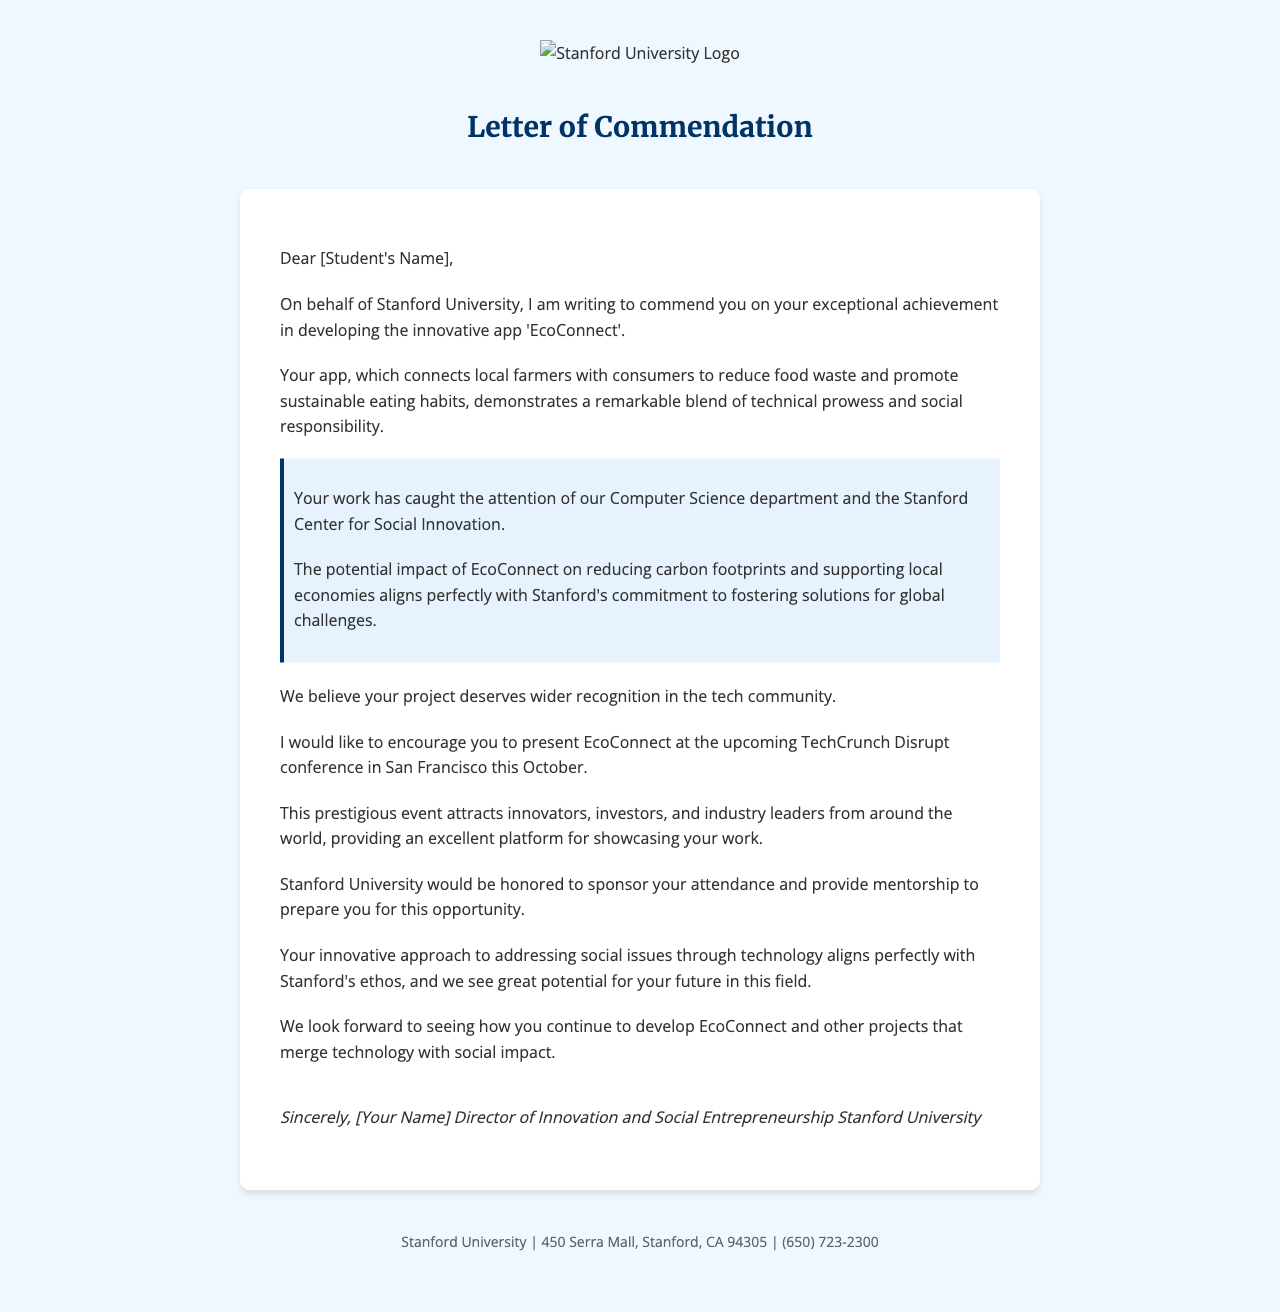What is the name of the app developed by the student? The letter clearly states the name of the app as 'EcoConnect'.
Answer: EcoConnect Who is the student being commended? The salutation addresses the student directly by name, which is Alex Chen.
Answer: Alex Chen What is the event where the student is encouraged to present? The letter mentions the specific conference where the student is invited to present their work, which is TechCrunch Disrupt.
Answer: TechCrunch Disrupt What city will the conference take place in? The conference details indicate it will be held in San Francisco.
Answer: San Francisco What are two key features of EcoConnect mentioned in the letter? The letter highlights the app's functions, specifically that it connects local farmers with consumers and reduces food waste.
Answer: Connects local farmers with consumers; Reduces food waste Which department at Stanford recognizes the student's work? The letter notes that the Computer Science department has recognized the student's achievement.
Answer: Computer Science department What is the date range of the TechCrunch Disrupt conference? The letter specifies the conference will occur from October 15-17, 2023.
Answer: October 15-17, 2023 What type of support does Stanford University offer the student? The letter mentions that the university would be honored to sponsor the student's attendance and provide mentorship.
Answer: Sponsor attendance and provide mentorship What is emphasized as a future potential for the student in the letter? The letter expresses that there is great potential for the student's future in the field of technology and social impact.
Answer: Great potential for your future in this field 